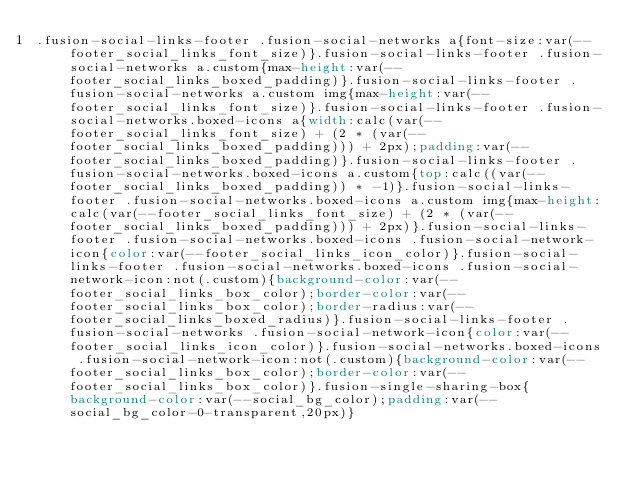Convert code to text. <code><loc_0><loc_0><loc_500><loc_500><_CSS_>.fusion-social-links-footer .fusion-social-networks a{font-size:var(--footer_social_links_font_size)}.fusion-social-links-footer .fusion-social-networks a.custom{max-height:var(--footer_social_links_boxed_padding)}.fusion-social-links-footer .fusion-social-networks a.custom img{max-height:var(--footer_social_links_font_size)}.fusion-social-links-footer .fusion-social-networks.boxed-icons a{width:calc(var(--footer_social_links_font_size) + (2 * (var(--footer_social_links_boxed_padding))) + 2px);padding:var(--footer_social_links_boxed_padding)}.fusion-social-links-footer .fusion-social-networks.boxed-icons a.custom{top:calc((var(--footer_social_links_boxed_padding)) * -1)}.fusion-social-links-footer .fusion-social-networks.boxed-icons a.custom img{max-height:calc(var(--footer_social_links_font_size) + (2 * (var(--footer_social_links_boxed_padding))) + 2px)}.fusion-social-links-footer .fusion-social-networks.boxed-icons .fusion-social-network-icon{color:var(--footer_social_links_icon_color)}.fusion-social-links-footer .fusion-social-networks.boxed-icons .fusion-social-network-icon:not(.custom){background-color:var(--footer_social_links_box_color);border-color:var(--footer_social_links_box_color);border-radius:var(--footer_social_links_boxed_radius)}.fusion-social-links-footer .fusion-social-networks .fusion-social-network-icon{color:var(--footer_social_links_icon_color)}.fusion-social-networks.boxed-icons .fusion-social-network-icon:not(.custom){background-color:var(--footer_social_links_box_color);border-color:var(--footer_social_links_box_color)}.fusion-single-sharing-box{background-color:var(--social_bg_color);padding:var(--social_bg_color-0-transparent,20px)}</code> 